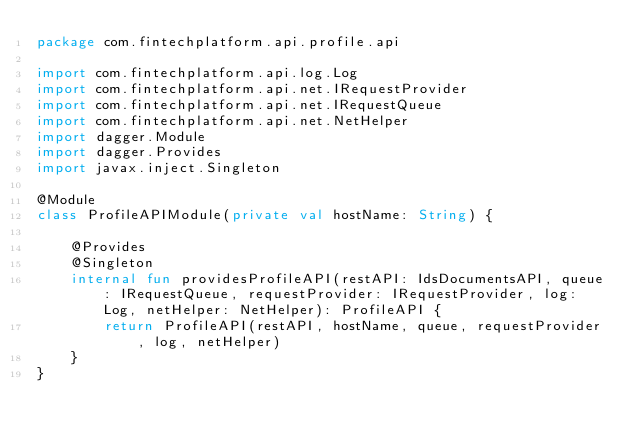<code> <loc_0><loc_0><loc_500><loc_500><_Kotlin_>package com.fintechplatform.api.profile.api

import com.fintechplatform.api.log.Log
import com.fintechplatform.api.net.IRequestProvider
import com.fintechplatform.api.net.IRequestQueue
import com.fintechplatform.api.net.NetHelper
import dagger.Module
import dagger.Provides
import javax.inject.Singleton

@Module
class ProfileAPIModule(private val hostName: String) {

    @Provides
    @Singleton
    internal fun providesProfileAPI(restAPI: IdsDocumentsAPI, queue: IRequestQueue, requestProvider: IRequestProvider, log: Log, netHelper: NetHelper): ProfileAPI {
        return ProfileAPI(restAPI, hostName, queue, requestProvider, log, netHelper)
    }
}
</code> 